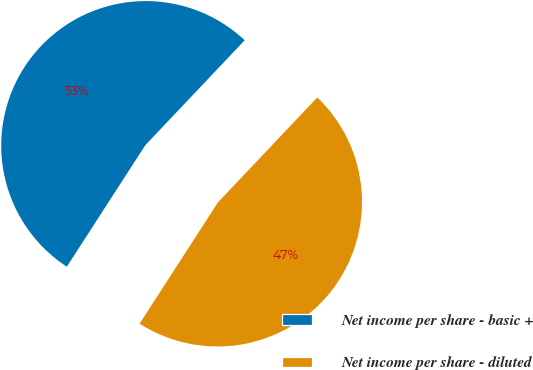Convert chart. <chart><loc_0><loc_0><loc_500><loc_500><pie_chart><fcel>Net income per share - basic +<fcel>Net income per share - diluted<nl><fcel>52.94%<fcel>47.06%<nl></chart> 